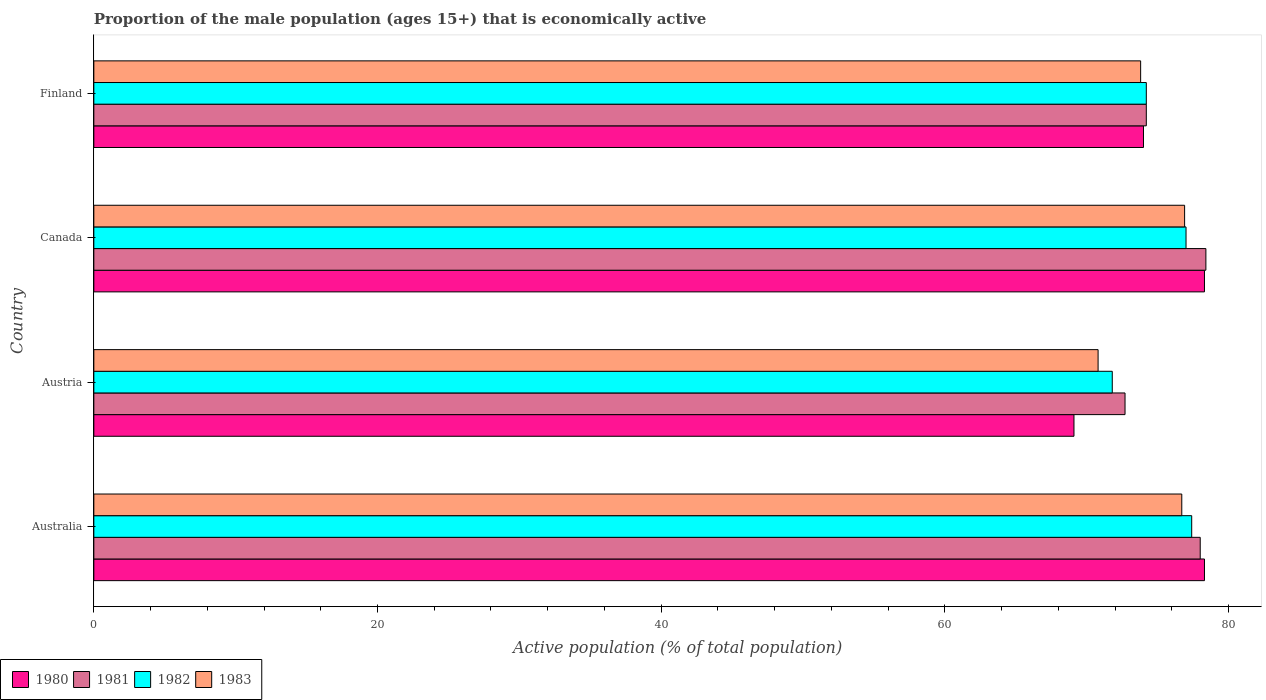How many groups of bars are there?
Keep it short and to the point. 4. Are the number of bars on each tick of the Y-axis equal?
Your answer should be very brief. Yes. How many bars are there on the 3rd tick from the bottom?
Your answer should be compact. 4. In how many cases, is the number of bars for a given country not equal to the number of legend labels?
Your answer should be very brief. 0. What is the proportion of the male population that is economically active in 1981 in Finland?
Make the answer very short. 74.2. Across all countries, what is the maximum proportion of the male population that is economically active in 1980?
Give a very brief answer. 78.3. Across all countries, what is the minimum proportion of the male population that is economically active in 1982?
Give a very brief answer. 71.8. In which country was the proportion of the male population that is economically active in 1982 minimum?
Your answer should be compact. Austria. What is the total proportion of the male population that is economically active in 1980 in the graph?
Provide a succinct answer. 299.7. What is the difference between the proportion of the male population that is economically active in 1982 in Australia and that in Austria?
Make the answer very short. 5.6. What is the difference between the proportion of the male population that is economically active in 1980 in Austria and the proportion of the male population that is economically active in 1982 in Australia?
Make the answer very short. -8.3. What is the average proportion of the male population that is economically active in 1983 per country?
Make the answer very short. 74.55. What is the difference between the proportion of the male population that is economically active in 1980 and proportion of the male population that is economically active in 1982 in Canada?
Make the answer very short. 1.3. In how many countries, is the proportion of the male population that is economically active in 1981 greater than 36 %?
Your answer should be very brief. 4. What is the ratio of the proportion of the male population that is economically active in 1981 in Australia to that in Finland?
Your response must be concise. 1.05. Is the difference between the proportion of the male population that is economically active in 1980 in Australia and Finland greater than the difference between the proportion of the male population that is economically active in 1982 in Australia and Finland?
Give a very brief answer. Yes. What is the difference between the highest and the second highest proportion of the male population that is economically active in 1980?
Offer a very short reply. 0. What is the difference between the highest and the lowest proportion of the male population that is economically active in 1981?
Your answer should be compact. 5.7. Is it the case that in every country, the sum of the proportion of the male population that is economically active in 1982 and proportion of the male population that is economically active in 1981 is greater than the sum of proportion of the male population that is economically active in 1983 and proportion of the male population that is economically active in 1980?
Give a very brief answer. No. How many bars are there?
Keep it short and to the point. 16. What is the difference between two consecutive major ticks on the X-axis?
Make the answer very short. 20. Does the graph contain any zero values?
Your answer should be very brief. No. Where does the legend appear in the graph?
Make the answer very short. Bottom left. How are the legend labels stacked?
Give a very brief answer. Horizontal. What is the title of the graph?
Your answer should be very brief. Proportion of the male population (ages 15+) that is economically active. What is the label or title of the X-axis?
Your answer should be compact. Active population (% of total population). What is the Active population (% of total population) of 1980 in Australia?
Provide a short and direct response. 78.3. What is the Active population (% of total population) of 1981 in Australia?
Offer a terse response. 78. What is the Active population (% of total population) in 1982 in Australia?
Your answer should be compact. 77.4. What is the Active population (% of total population) in 1983 in Australia?
Provide a short and direct response. 76.7. What is the Active population (% of total population) in 1980 in Austria?
Keep it short and to the point. 69.1. What is the Active population (% of total population) of 1981 in Austria?
Provide a succinct answer. 72.7. What is the Active population (% of total population) in 1982 in Austria?
Provide a succinct answer. 71.8. What is the Active population (% of total population) in 1983 in Austria?
Give a very brief answer. 70.8. What is the Active population (% of total population) in 1980 in Canada?
Provide a succinct answer. 78.3. What is the Active population (% of total population) in 1981 in Canada?
Your response must be concise. 78.4. What is the Active population (% of total population) in 1982 in Canada?
Your response must be concise. 77. What is the Active population (% of total population) of 1983 in Canada?
Ensure brevity in your answer.  76.9. What is the Active population (% of total population) of 1980 in Finland?
Your answer should be very brief. 74. What is the Active population (% of total population) in 1981 in Finland?
Provide a succinct answer. 74.2. What is the Active population (% of total population) of 1982 in Finland?
Provide a short and direct response. 74.2. What is the Active population (% of total population) of 1983 in Finland?
Provide a short and direct response. 73.8. Across all countries, what is the maximum Active population (% of total population) of 1980?
Keep it short and to the point. 78.3. Across all countries, what is the maximum Active population (% of total population) in 1981?
Keep it short and to the point. 78.4. Across all countries, what is the maximum Active population (% of total population) of 1982?
Your answer should be compact. 77.4. Across all countries, what is the maximum Active population (% of total population) in 1983?
Provide a short and direct response. 76.9. Across all countries, what is the minimum Active population (% of total population) in 1980?
Your answer should be compact. 69.1. Across all countries, what is the minimum Active population (% of total population) in 1981?
Make the answer very short. 72.7. Across all countries, what is the minimum Active population (% of total population) in 1982?
Your response must be concise. 71.8. Across all countries, what is the minimum Active population (% of total population) of 1983?
Keep it short and to the point. 70.8. What is the total Active population (% of total population) of 1980 in the graph?
Offer a terse response. 299.7. What is the total Active population (% of total population) of 1981 in the graph?
Make the answer very short. 303.3. What is the total Active population (% of total population) of 1982 in the graph?
Keep it short and to the point. 300.4. What is the total Active population (% of total population) of 1983 in the graph?
Your answer should be very brief. 298.2. What is the difference between the Active population (% of total population) of 1981 in Australia and that in Austria?
Offer a very short reply. 5.3. What is the difference between the Active population (% of total population) in 1982 in Australia and that in Austria?
Ensure brevity in your answer.  5.6. What is the difference between the Active population (% of total population) in 1982 in Australia and that in Canada?
Make the answer very short. 0.4. What is the difference between the Active population (% of total population) of 1983 in Australia and that in Canada?
Offer a very short reply. -0.2. What is the difference between the Active population (% of total population) in 1980 in Australia and that in Finland?
Your answer should be very brief. 4.3. What is the difference between the Active population (% of total population) in 1981 in Australia and that in Finland?
Make the answer very short. 3.8. What is the difference between the Active population (% of total population) in 1983 in Australia and that in Finland?
Offer a very short reply. 2.9. What is the difference between the Active population (% of total population) of 1981 in Austria and that in Canada?
Give a very brief answer. -5.7. What is the difference between the Active population (% of total population) in 1983 in Austria and that in Canada?
Make the answer very short. -6.1. What is the difference between the Active population (% of total population) of 1980 in Austria and that in Finland?
Keep it short and to the point. -4.9. What is the difference between the Active population (% of total population) in 1981 in Austria and that in Finland?
Give a very brief answer. -1.5. What is the difference between the Active population (% of total population) in 1982 in Austria and that in Finland?
Provide a short and direct response. -2.4. What is the difference between the Active population (% of total population) in 1980 in Canada and that in Finland?
Your response must be concise. 4.3. What is the difference between the Active population (% of total population) of 1981 in Canada and that in Finland?
Your answer should be compact. 4.2. What is the difference between the Active population (% of total population) in 1982 in Canada and that in Finland?
Offer a terse response. 2.8. What is the difference between the Active population (% of total population) in 1980 in Australia and the Active population (% of total population) in 1981 in Austria?
Your answer should be very brief. 5.6. What is the difference between the Active population (% of total population) in 1980 in Australia and the Active population (% of total population) in 1982 in Austria?
Your answer should be compact. 6.5. What is the difference between the Active population (% of total population) in 1981 in Australia and the Active population (% of total population) in 1982 in Austria?
Your response must be concise. 6.2. What is the difference between the Active population (% of total population) in 1981 in Australia and the Active population (% of total population) in 1983 in Austria?
Give a very brief answer. 7.2. What is the difference between the Active population (% of total population) in 1980 in Australia and the Active population (% of total population) in 1981 in Canada?
Ensure brevity in your answer.  -0.1. What is the difference between the Active population (% of total population) in 1982 in Australia and the Active population (% of total population) in 1983 in Canada?
Make the answer very short. 0.5. What is the difference between the Active population (% of total population) in 1980 in Australia and the Active population (% of total population) in 1981 in Finland?
Provide a succinct answer. 4.1. What is the difference between the Active population (% of total population) of 1981 in Australia and the Active population (% of total population) of 1982 in Finland?
Provide a short and direct response. 3.8. What is the difference between the Active population (% of total population) of 1980 in Austria and the Active population (% of total population) of 1982 in Canada?
Offer a very short reply. -7.9. What is the difference between the Active population (% of total population) in 1980 in Austria and the Active population (% of total population) in 1983 in Canada?
Provide a succinct answer. -7.8. What is the difference between the Active population (% of total population) in 1981 in Austria and the Active population (% of total population) in 1982 in Canada?
Provide a short and direct response. -4.3. What is the difference between the Active population (% of total population) of 1981 in Austria and the Active population (% of total population) of 1983 in Canada?
Ensure brevity in your answer.  -4.2. What is the difference between the Active population (% of total population) in 1982 in Austria and the Active population (% of total population) in 1983 in Canada?
Keep it short and to the point. -5.1. What is the difference between the Active population (% of total population) of 1980 in Austria and the Active population (% of total population) of 1981 in Finland?
Offer a very short reply. -5.1. What is the difference between the Active population (% of total population) of 1980 in Austria and the Active population (% of total population) of 1982 in Finland?
Provide a succinct answer. -5.1. What is the difference between the Active population (% of total population) of 1982 in Austria and the Active population (% of total population) of 1983 in Finland?
Provide a short and direct response. -2. What is the difference between the Active population (% of total population) in 1980 in Canada and the Active population (% of total population) in 1981 in Finland?
Make the answer very short. 4.1. What is the difference between the Active population (% of total population) in 1980 in Canada and the Active population (% of total population) in 1982 in Finland?
Provide a short and direct response. 4.1. What is the difference between the Active population (% of total population) of 1980 in Canada and the Active population (% of total population) of 1983 in Finland?
Offer a terse response. 4.5. What is the difference between the Active population (% of total population) in 1981 in Canada and the Active population (% of total population) in 1983 in Finland?
Your response must be concise. 4.6. What is the difference between the Active population (% of total population) of 1982 in Canada and the Active population (% of total population) of 1983 in Finland?
Offer a terse response. 3.2. What is the average Active population (% of total population) of 1980 per country?
Ensure brevity in your answer.  74.92. What is the average Active population (% of total population) in 1981 per country?
Give a very brief answer. 75.83. What is the average Active population (% of total population) in 1982 per country?
Your answer should be very brief. 75.1. What is the average Active population (% of total population) of 1983 per country?
Provide a short and direct response. 74.55. What is the difference between the Active population (% of total population) of 1980 and Active population (% of total population) of 1981 in Australia?
Make the answer very short. 0.3. What is the difference between the Active population (% of total population) of 1980 and Active population (% of total population) of 1982 in Australia?
Your response must be concise. 0.9. What is the difference between the Active population (% of total population) in 1980 and Active population (% of total population) in 1983 in Australia?
Make the answer very short. 1.6. What is the difference between the Active population (% of total population) in 1981 and Active population (% of total population) in 1982 in Australia?
Provide a short and direct response. 0.6. What is the difference between the Active population (% of total population) in 1980 and Active population (% of total population) in 1982 in Austria?
Ensure brevity in your answer.  -2.7. What is the difference between the Active population (% of total population) of 1980 and Active population (% of total population) of 1983 in Austria?
Ensure brevity in your answer.  -1.7. What is the difference between the Active population (% of total population) of 1981 and Active population (% of total population) of 1983 in Canada?
Provide a short and direct response. 1.5. What is the difference between the Active population (% of total population) in 1982 and Active population (% of total population) in 1983 in Canada?
Offer a terse response. 0.1. What is the difference between the Active population (% of total population) of 1980 and Active population (% of total population) of 1981 in Finland?
Keep it short and to the point. -0.2. What is the difference between the Active population (% of total population) of 1980 and Active population (% of total population) of 1982 in Finland?
Provide a short and direct response. -0.2. What is the difference between the Active population (% of total population) in 1981 and Active population (% of total population) in 1982 in Finland?
Keep it short and to the point. 0. What is the difference between the Active population (% of total population) in 1981 and Active population (% of total population) in 1983 in Finland?
Your answer should be very brief. 0.4. What is the difference between the Active population (% of total population) in 1982 and Active population (% of total population) in 1983 in Finland?
Make the answer very short. 0.4. What is the ratio of the Active population (% of total population) in 1980 in Australia to that in Austria?
Your answer should be compact. 1.13. What is the ratio of the Active population (% of total population) in 1981 in Australia to that in Austria?
Ensure brevity in your answer.  1.07. What is the ratio of the Active population (% of total population) in 1982 in Australia to that in Austria?
Ensure brevity in your answer.  1.08. What is the ratio of the Active population (% of total population) in 1980 in Australia to that in Canada?
Offer a very short reply. 1. What is the ratio of the Active population (% of total population) in 1980 in Australia to that in Finland?
Keep it short and to the point. 1.06. What is the ratio of the Active population (% of total population) of 1981 in Australia to that in Finland?
Your response must be concise. 1.05. What is the ratio of the Active population (% of total population) of 1982 in Australia to that in Finland?
Provide a short and direct response. 1.04. What is the ratio of the Active population (% of total population) of 1983 in Australia to that in Finland?
Provide a succinct answer. 1.04. What is the ratio of the Active population (% of total population) of 1980 in Austria to that in Canada?
Give a very brief answer. 0.88. What is the ratio of the Active population (% of total population) in 1981 in Austria to that in Canada?
Your response must be concise. 0.93. What is the ratio of the Active population (% of total population) of 1982 in Austria to that in Canada?
Your answer should be very brief. 0.93. What is the ratio of the Active population (% of total population) of 1983 in Austria to that in Canada?
Offer a very short reply. 0.92. What is the ratio of the Active population (% of total population) in 1980 in Austria to that in Finland?
Provide a short and direct response. 0.93. What is the ratio of the Active population (% of total population) in 1981 in Austria to that in Finland?
Offer a very short reply. 0.98. What is the ratio of the Active population (% of total population) in 1982 in Austria to that in Finland?
Your answer should be very brief. 0.97. What is the ratio of the Active population (% of total population) in 1983 in Austria to that in Finland?
Keep it short and to the point. 0.96. What is the ratio of the Active population (% of total population) in 1980 in Canada to that in Finland?
Offer a terse response. 1.06. What is the ratio of the Active population (% of total population) in 1981 in Canada to that in Finland?
Provide a short and direct response. 1.06. What is the ratio of the Active population (% of total population) of 1982 in Canada to that in Finland?
Make the answer very short. 1.04. What is the ratio of the Active population (% of total population) in 1983 in Canada to that in Finland?
Give a very brief answer. 1.04. What is the difference between the highest and the second highest Active population (% of total population) of 1981?
Provide a short and direct response. 0.4. What is the difference between the highest and the lowest Active population (% of total population) in 1983?
Your response must be concise. 6.1. 